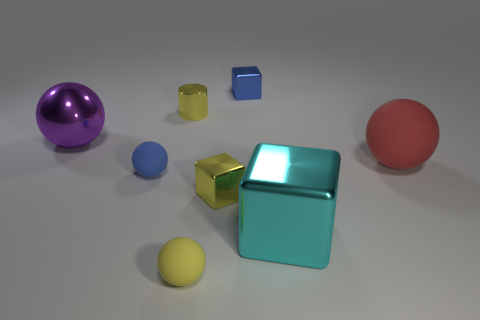Is the large cyan block made of the same material as the small yellow object that is behind the big purple sphere?
Your answer should be very brief. Yes. What is the shape of the yellow thing behind the large shiny sphere?
Offer a very short reply. Cylinder. What number of other objects are the same material as the big red sphere?
Provide a short and direct response. 2. What is the size of the blue metallic thing?
Keep it short and to the point. Small. How many other objects are there of the same color as the large metallic block?
Provide a short and direct response. 0. There is a metallic cube that is in front of the purple ball and to the left of the cyan shiny cube; what color is it?
Keep it short and to the point. Yellow. How many large purple shiny cubes are there?
Offer a terse response. 0. Is the big purple ball made of the same material as the large cyan block?
Give a very brief answer. Yes. What is the shape of the blue object behind the ball that is behind the rubber thing that is on the right side of the big shiny block?
Keep it short and to the point. Cube. Is the thing that is in front of the big cyan thing made of the same material as the small object on the left side of the tiny yellow cylinder?
Make the answer very short. Yes. 